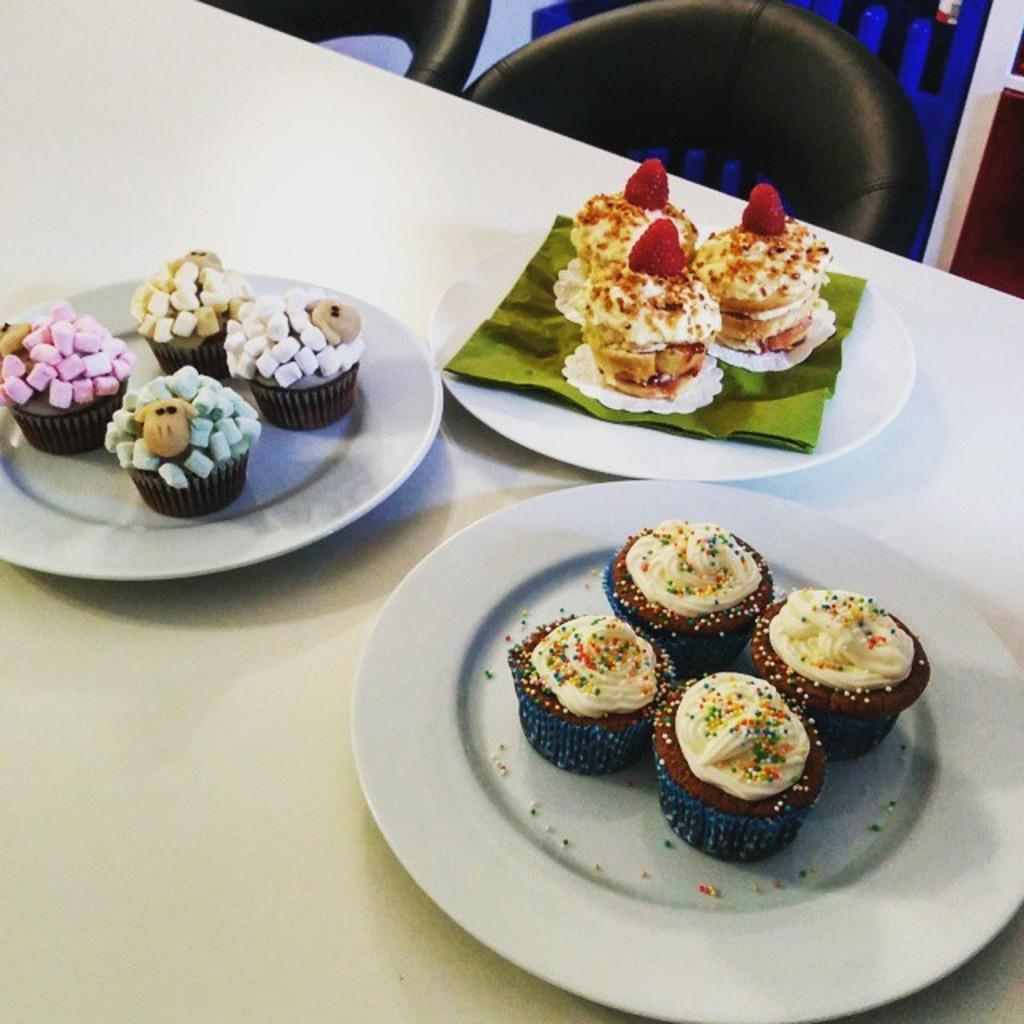Can you describe this image briefly? In this picture we can see some food items on the plates. There is a green object visible in one of the plates. These plates are visible on a table. We can see a few chairs on top of the picture. 